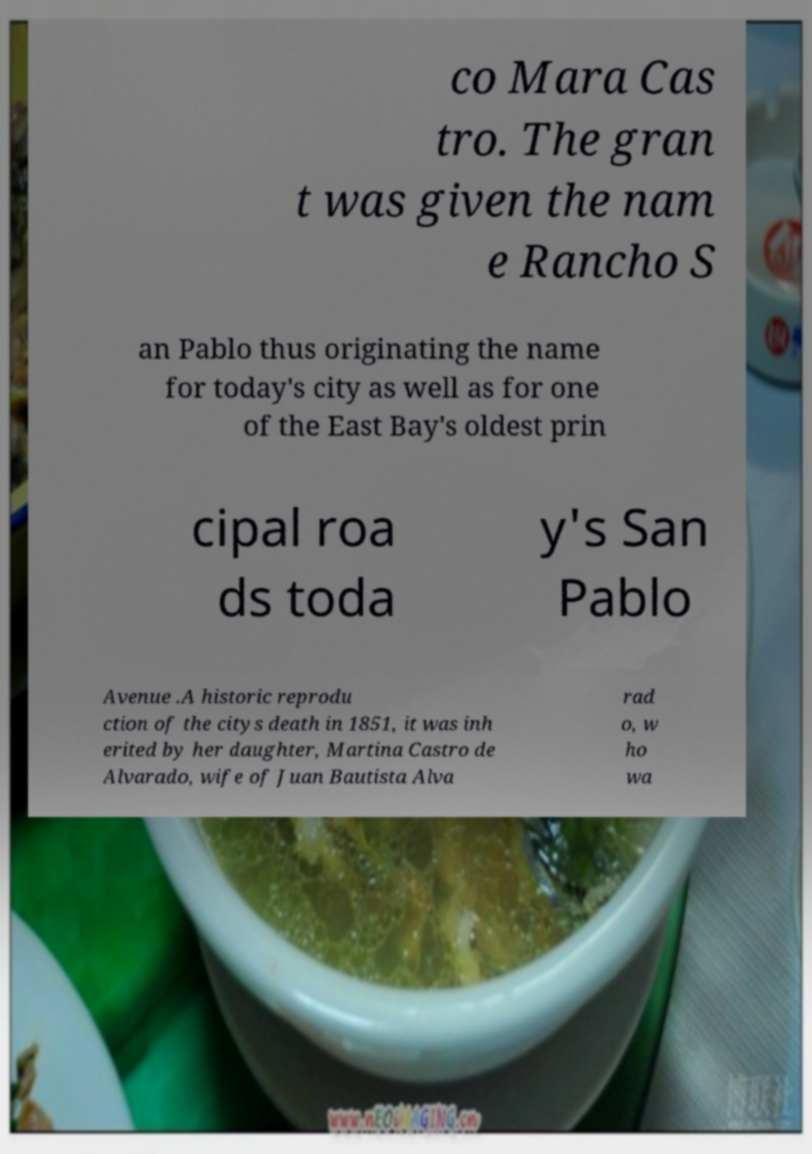Can you read and provide the text displayed in the image?This photo seems to have some interesting text. Can you extract and type it out for me? co Mara Cas tro. The gran t was given the nam e Rancho S an Pablo thus originating the name for today's city as well as for one of the East Bay's oldest prin cipal roa ds toda y's San Pablo Avenue .A historic reprodu ction of the citys death in 1851, it was inh erited by her daughter, Martina Castro de Alvarado, wife of Juan Bautista Alva rad o, w ho wa 